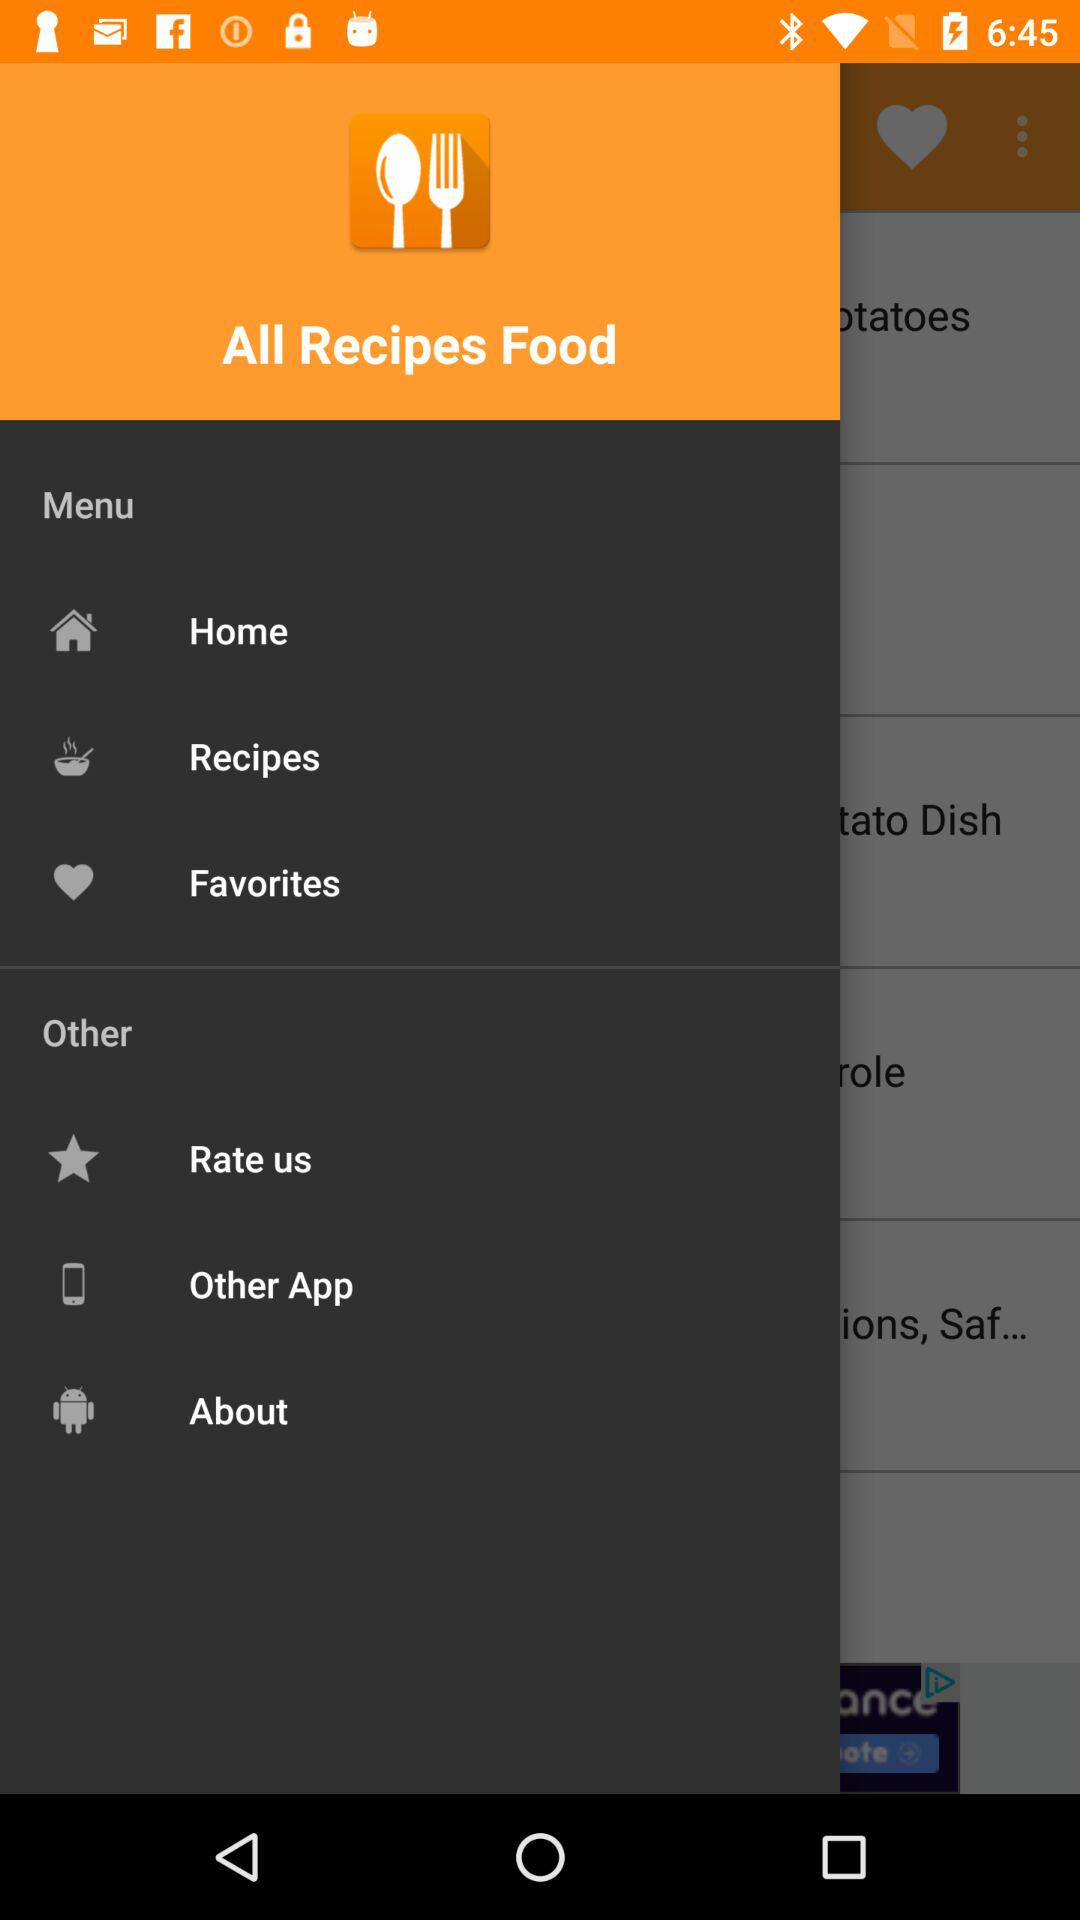How many more items are in the 'Other' section than in the 'Favorites' section?
Answer the question using a single word or phrase. 3 